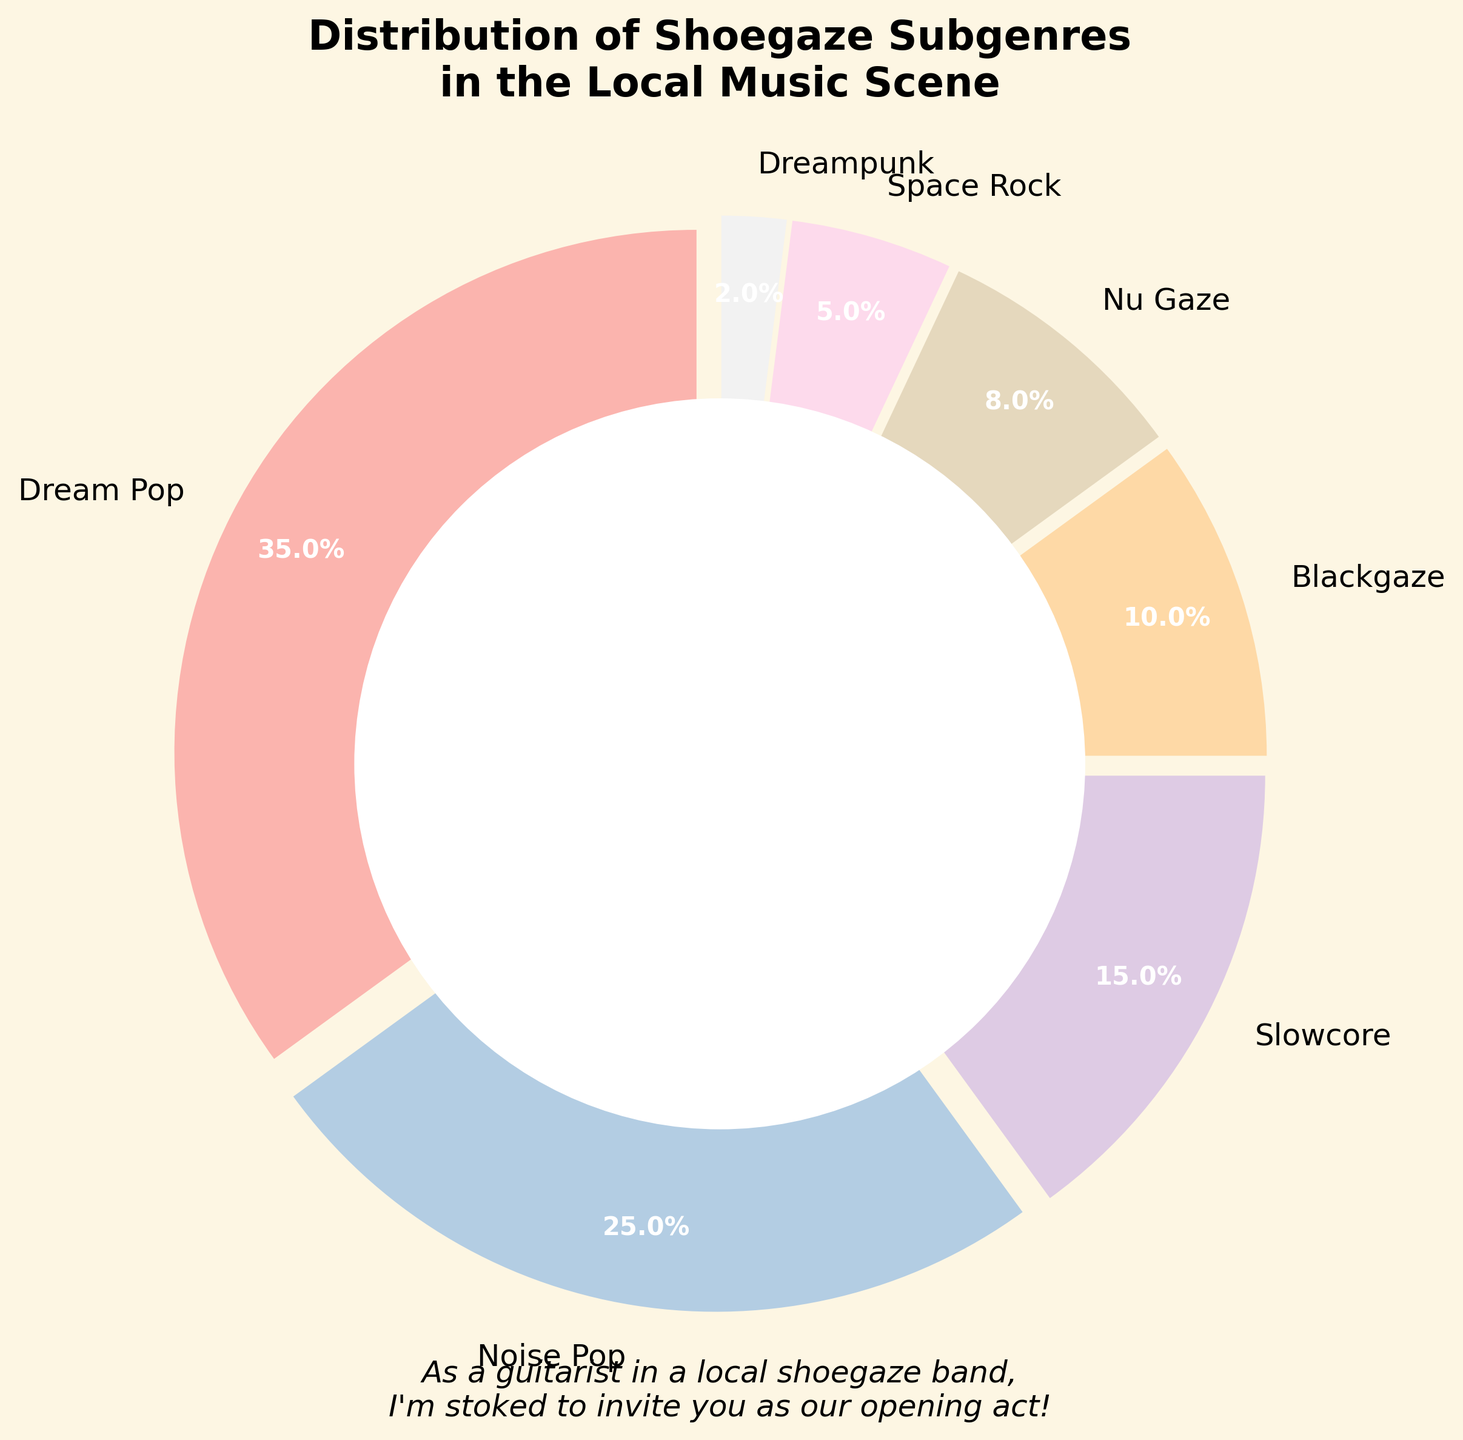What percentage of the local music scene is comprised of subgenres other than Dream Pop and Noise Pop? To find the percentage of subgenres excluding Dream Pop and Noise Pop, we sum the percentages of the remaining subgenres: Slowcore (15%) + Blackgaze (10%) + Nu Gaze (8%) + Space Rock (5%) + Dreampunk (2%) = 40%.
Answer: 40% Which subgenre has a larger share, Blackgaze or Nu Gaze? By looking at the pie chart, Blackgaze has 10% and Nu Gaze has 8%. Thus, Blackgaze has a larger share.
Answer: Blackgaze What two subgenres combined make up less than 10% of the local music scene? We need to find two subgenres whose combined percentages are less than 10%. The subgenres Space Rock (5%) and Dreampunk (2%) combined equal 7%, which is less than 10%.
Answer: Space Rock and Dreampunk What is the smallest percentage represented in the pie chart? By observing the pie chart, the smallest percentage is Dreampunk, which is 2%.
Answer: 2% How much more prevalent is Dream Pop compared to Blackgaze in the local music scene? Dream Pop is at 35% and Blackgaze is at 10%. The difference between them is 35% - 10% = 25%.
Answer: 25% If you combine Dream Pop, Noise Pop, and Slowcore, what percentage of the local music scene do they represent? Summing these subgenres gives: Dream Pop (35%) + Noise Pop (25%) + Slowcore (15%) = 75%.
Answer: 75% Which subgenre has a larger share, Slowcore or Space Rock? Observing the pie chart, Slowcore has 15% and Space Rock has 5%. Thus, Slowcore has a larger share.
Answer: Slowcore What percentage of the local music scene is captured by the two least prevalent subgenres? The least prevalent subgenres are Space Rock (5%) and Dreampunk (2%). Combined, they make up 5% + 2% = 7%.
Answer: 7% 